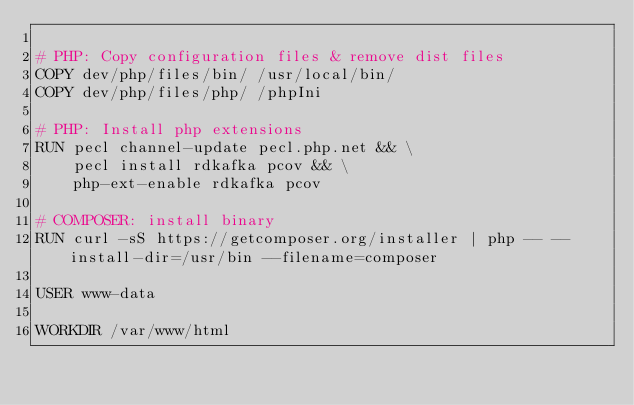Convert code to text. <code><loc_0><loc_0><loc_500><loc_500><_Dockerfile_>
# PHP: Copy configuration files & remove dist files
COPY dev/php/files/bin/ /usr/local/bin/
COPY dev/php/files/php/ /phpIni

# PHP: Install php extensions
RUN pecl channel-update pecl.php.net && \
    pecl install rdkafka pcov && \
    php-ext-enable rdkafka pcov

# COMPOSER: install binary
RUN curl -sS https://getcomposer.org/installer | php -- --install-dir=/usr/bin --filename=composer

USER www-data

WORKDIR /var/www/html
</code> 